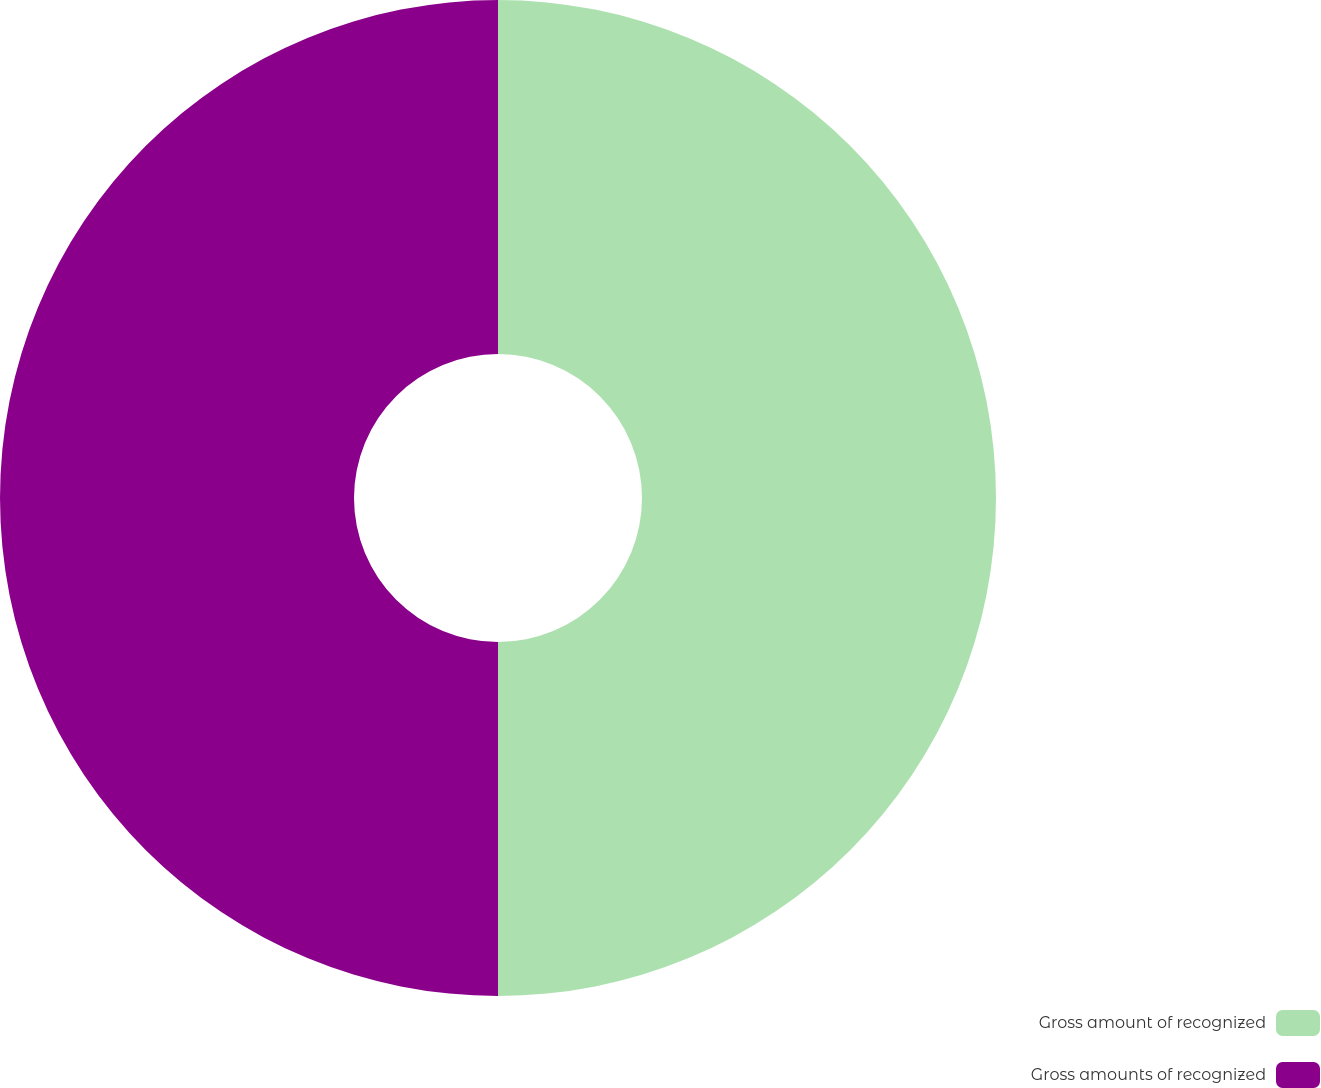Convert chart. <chart><loc_0><loc_0><loc_500><loc_500><pie_chart><fcel>Gross amount of recognized<fcel>Gross amounts of recognized<nl><fcel>50.0%<fcel>50.0%<nl></chart> 